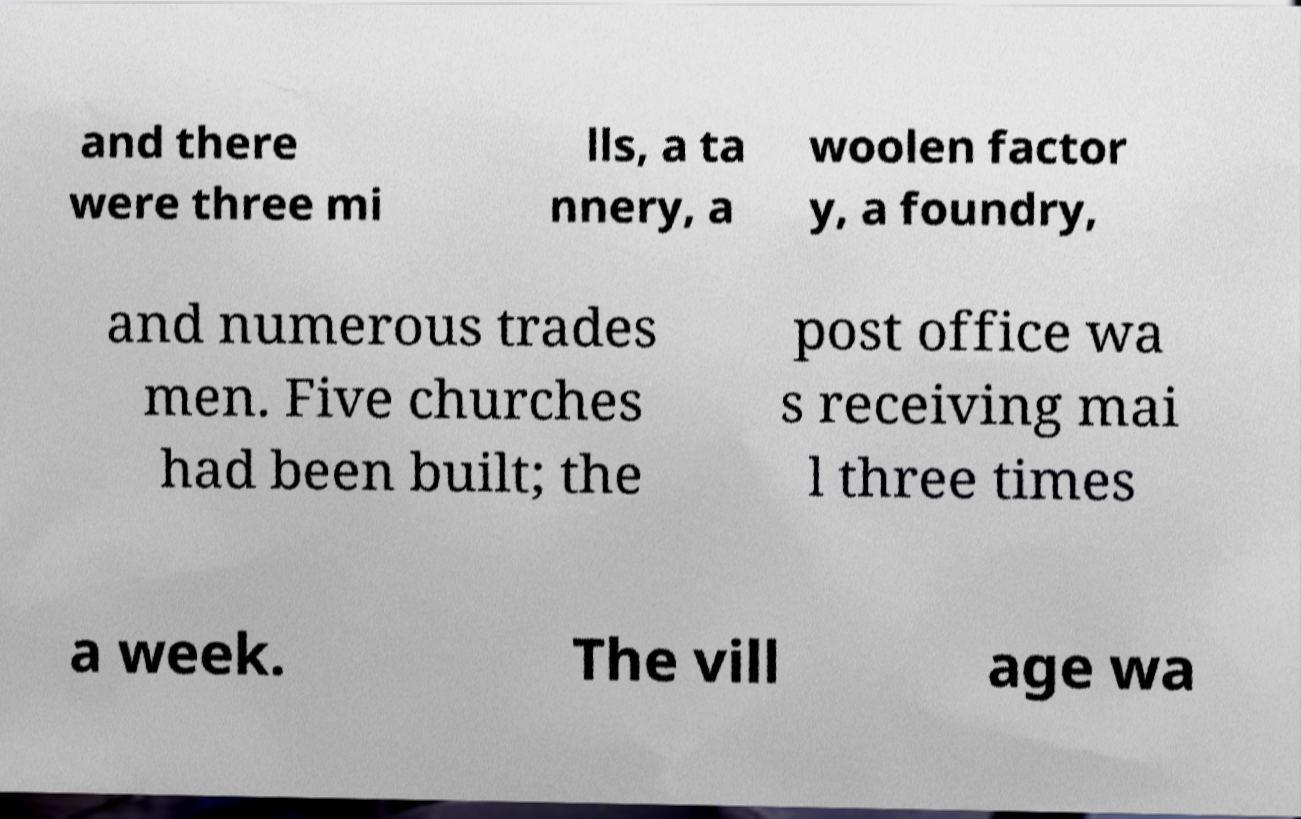I need the written content from this picture converted into text. Can you do that? and there were three mi lls, a ta nnery, a woolen factor y, a foundry, and numerous trades men. Five churches had been built; the post office wa s receiving mai l three times a week. The vill age wa 